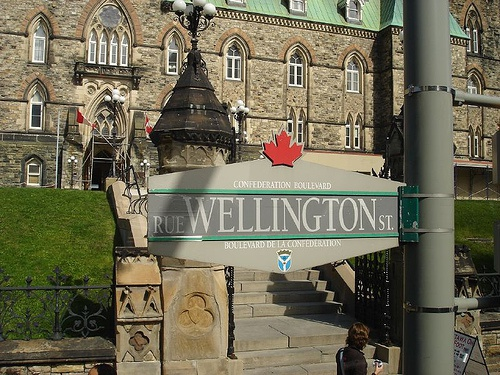Describe the objects in this image and their specific colors. I can see people in tan, black, gray, and maroon tones in this image. 